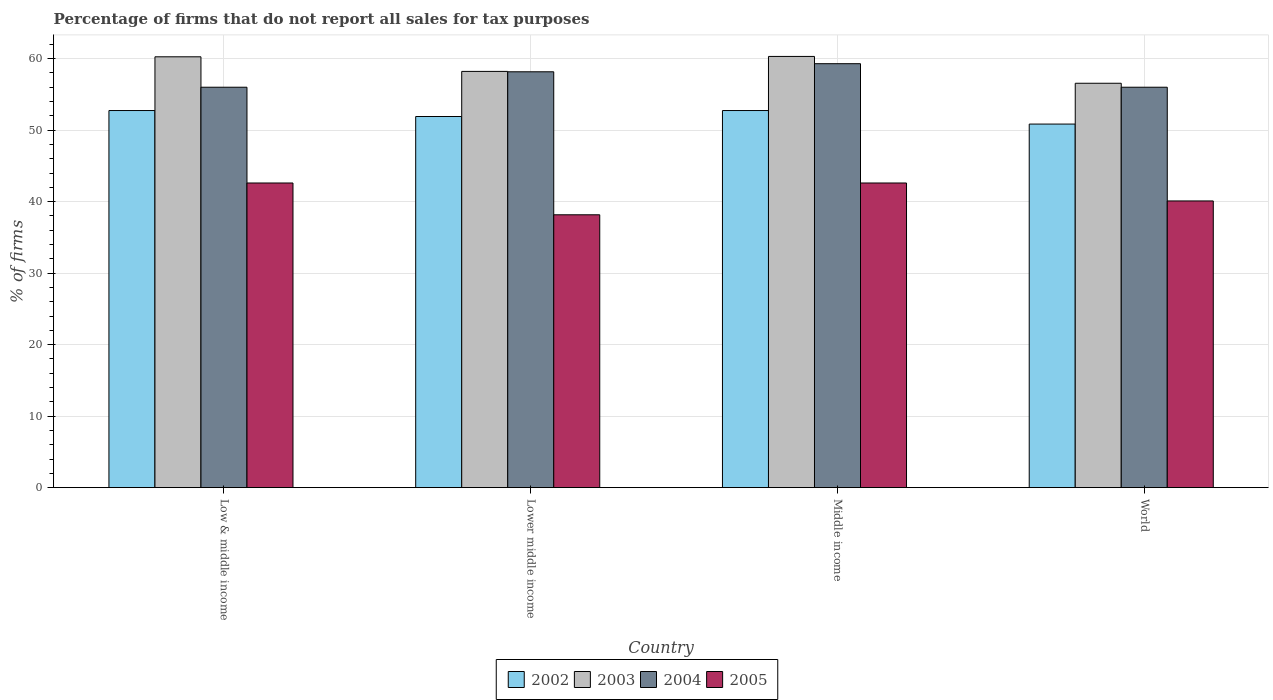How many bars are there on the 3rd tick from the left?
Provide a succinct answer. 4. In how many cases, is the number of bars for a given country not equal to the number of legend labels?
Provide a short and direct response. 0. What is the percentage of firms that do not report all sales for tax purposes in 2002 in Middle income?
Your response must be concise. 52.75. Across all countries, what is the maximum percentage of firms that do not report all sales for tax purposes in 2004?
Ensure brevity in your answer.  59.3. Across all countries, what is the minimum percentage of firms that do not report all sales for tax purposes in 2005?
Give a very brief answer. 38.16. What is the total percentage of firms that do not report all sales for tax purposes in 2005 in the graph?
Your response must be concise. 163.48. What is the difference between the percentage of firms that do not report all sales for tax purposes in 2004 in Lower middle income and that in World?
Offer a terse response. 2.16. What is the difference between the percentage of firms that do not report all sales for tax purposes in 2003 in Low & middle income and the percentage of firms that do not report all sales for tax purposes in 2004 in Middle income?
Keep it short and to the point. 0.96. What is the average percentage of firms that do not report all sales for tax purposes in 2004 per country?
Provide a short and direct response. 57.37. What is the difference between the percentage of firms that do not report all sales for tax purposes of/in 2005 and percentage of firms that do not report all sales for tax purposes of/in 2004 in World?
Make the answer very short. -15.91. What is the ratio of the percentage of firms that do not report all sales for tax purposes in 2004 in Middle income to that in World?
Offer a very short reply. 1.06. Is the percentage of firms that do not report all sales for tax purposes in 2002 in Lower middle income less than that in World?
Your answer should be compact. No. Is the difference between the percentage of firms that do not report all sales for tax purposes in 2005 in Lower middle income and World greater than the difference between the percentage of firms that do not report all sales for tax purposes in 2004 in Lower middle income and World?
Provide a short and direct response. No. What is the difference between the highest and the second highest percentage of firms that do not report all sales for tax purposes in 2005?
Ensure brevity in your answer.  -2.51. What is the difference between the highest and the lowest percentage of firms that do not report all sales for tax purposes in 2004?
Provide a short and direct response. 3.29. In how many countries, is the percentage of firms that do not report all sales for tax purposes in 2004 greater than the average percentage of firms that do not report all sales for tax purposes in 2004 taken over all countries?
Offer a very short reply. 2. Is the sum of the percentage of firms that do not report all sales for tax purposes in 2004 in Low & middle income and Middle income greater than the maximum percentage of firms that do not report all sales for tax purposes in 2002 across all countries?
Keep it short and to the point. Yes. Is it the case that in every country, the sum of the percentage of firms that do not report all sales for tax purposes in 2002 and percentage of firms that do not report all sales for tax purposes in 2004 is greater than the sum of percentage of firms that do not report all sales for tax purposes in 2003 and percentage of firms that do not report all sales for tax purposes in 2005?
Offer a very short reply. No. What does the 4th bar from the left in Middle income represents?
Offer a very short reply. 2005. What does the 4th bar from the right in World represents?
Ensure brevity in your answer.  2002. Is it the case that in every country, the sum of the percentage of firms that do not report all sales for tax purposes in 2002 and percentage of firms that do not report all sales for tax purposes in 2003 is greater than the percentage of firms that do not report all sales for tax purposes in 2004?
Your response must be concise. Yes. How many bars are there?
Offer a terse response. 16. Are all the bars in the graph horizontal?
Your answer should be compact. No. How many countries are there in the graph?
Your answer should be compact. 4. What is the difference between two consecutive major ticks on the Y-axis?
Give a very brief answer. 10. Are the values on the major ticks of Y-axis written in scientific E-notation?
Ensure brevity in your answer.  No. Does the graph contain any zero values?
Offer a very short reply. No. Where does the legend appear in the graph?
Your answer should be compact. Bottom center. How are the legend labels stacked?
Ensure brevity in your answer.  Horizontal. What is the title of the graph?
Offer a terse response. Percentage of firms that do not report all sales for tax purposes. Does "2005" appear as one of the legend labels in the graph?
Give a very brief answer. Yes. What is the label or title of the X-axis?
Ensure brevity in your answer.  Country. What is the label or title of the Y-axis?
Your response must be concise. % of firms. What is the % of firms of 2002 in Low & middle income?
Offer a very short reply. 52.75. What is the % of firms of 2003 in Low & middle income?
Offer a terse response. 60.26. What is the % of firms of 2004 in Low & middle income?
Provide a succinct answer. 56.01. What is the % of firms of 2005 in Low & middle income?
Offer a terse response. 42.61. What is the % of firms of 2002 in Lower middle income?
Make the answer very short. 51.91. What is the % of firms of 2003 in Lower middle income?
Your response must be concise. 58.22. What is the % of firms of 2004 in Lower middle income?
Provide a succinct answer. 58.16. What is the % of firms in 2005 in Lower middle income?
Provide a succinct answer. 38.16. What is the % of firms of 2002 in Middle income?
Provide a short and direct response. 52.75. What is the % of firms in 2003 in Middle income?
Keep it short and to the point. 60.31. What is the % of firms of 2004 in Middle income?
Your response must be concise. 59.3. What is the % of firms in 2005 in Middle income?
Provide a short and direct response. 42.61. What is the % of firms of 2002 in World?
Keep it short and to the point. 50.85. What is the % of firms in 2003 in World?
Provide a short and direct response. 56.56. What is the % of firms in 2004 in World?
Provide a succinct answer. 56.01. What is the % of firms in 2005 in World?
Give a very brief answer. 40.1. Across all countries, what is the maximum % of firms in 2002?
Provide a succinct answer. 52.75. Across all countries, what is the maximum % of firms in 2003?
Offer a very short reply. 60.31. Across all countries, what is the maximum % of firms in 2004?
Ensure brevity in your answer.  59.3. Across all countries, what is the maximum % of firms in 2005?
Offer a very short reply. 42.61. Across all countries, what is the minimum % of firms in 2002?
Your response must be concise. 50.85. Across all countries, what is the minimum % of firms of 2003?
Your response must be concise. 56.56. Across all countries, what is the minimum % of firms of 2004?
Offer a terse response. 56.01. Across all countries, what is the minimum % of firms in 2005?
Ensure brevity in your answer.  38.16. What is the total % of firms in 2002 in the graph?
Your answer should be very brief. 208.25. What is the total % of firms in 2003 in the graph?
Give a very brief answer. 235.35. What is the total % of firms in 2004 in the graph?
Your answer should be compact. 229.47. What is the total % of firms in 2005 in the graph?
Provide a short and direct response. 163.48. What is the difference between the % of firms of 2002 in Low & middle income and that in Lower middle income?
Provide a short and direct response. 0.84. What is the difference between the % of firms of 2003 in Low & middle income and that in Lower middle income?
Offer a terse response. 2.04. What is the difference between the % of firms in 2004 in Low & middle income and that in Lower middle income?
Ensure brevity in your answer.  -2.16. What is the difference between the % of firms of 2005 in Low & middle income and that in Lower middle income?
Ensure brevity in your answer.  4.45. What is the difference between the % of firms of 2002 in Low & middle income and that in Middle income?
Keep it short and to the point. 0. What is the difference between the % of firms in 2003 in Low & middle income and that in Middle income?
Your answer should be compact. -0.05. What is the difference between the % of firms of 2004 in Low & middle income and that in Middle income?
Your answer should be compact. -3.29. What is the difference between the % of firms of 2002 in Low & middle income and that in World?
Your answer should be very brief. 1.89. What is the difference between the % of firms of 2003 in Low & middle income and that in World?
Your answer should be compact. 3.7. What is the difference between the % of firms of 2004 in Low & middle income and that in World?
Your answer should be compact. 0. What is the difference between the % of firms in 2005 in Low & middle income and that in World?
Give a very brief answer. 2.51. What is the difference between the % of firms of 2002 in Lower middle income and that in Middle income?
Make the answer very short. -0.84. What is the difference between the % of firms in 2003 in Lower middle income and that in Middle income?
Ensure brevity in your answer.  -2.09. What is the difference between the % of firms of 2004 in Lower middle income and that in Middle income?
Give a very brief answer. -1.13. What is the difference between the % of firms in 2005 in Lower middle income and that in Middle income?
Offer a very short reply. -4.45. What is the difference between the % of firms in 2002 in Lower middle income and that in World?
Your answer should be very brief. 1.06. What is the difference between the % of firms of 2003 in Lower middle income and that in World?
Your response must be concise. 1.66. What is the difference between the % of firms in 2004 in Lower middle income and that in World?
Provide a short and direct response. 2.16. What is the difference between the % of firms of 2005 in Lower middle income and that in World?
Provide a succinct answer. -1.94. What is the difference between the % of firms in 2002 in Middle income and that in World?
Keep it short and to the point. 1.89. What is the difference between the % of firms of 2003 in Middle income and that in World?
Make the answer very short. 3.75. What is the difference between the % of firms in 2004 in Middle income and that in World?
Provide a short and direct response. 3.29. What is the difference between the % of firms of 2005 in Middle income and that in World?
Ensure brevity in your answer.  2.51. What is the difference between the % of firms of 2002 in Low & middle income and the % of firms of 2003 in Lower middle income?
Give a very brief answer. -5.47. What is the difference between the % of firms of 2002 in Low & middle income and the % of firms of 2004 in Lower middle income?
Make the answer very short. -5.42. What is the difference between the % of firms in 2002 in Low & middle income and the % of firms in 2005 in Lower middle income?
Ensure brevity in your answer.  14.58. What is the difference between the % of firms in 2003 in Low & middle income and the % of firms in 2004 in Lower middle income?
Provide a short and direct response. 2.1. What is the difference between the % of firms of 2003 in Low & middle income and the % of firms of 2005 in Lower middle income?
Provide a short and direct response. 22.1. What is the difference between the % of firms of 2004 in Low & middle income and the % of firms of 2005 in Lower middle income?
Your answer should be very brief. 17.84. What is the difference between the % of firms in 2002 in Low & middle income and the % of firms in 2003 in Middle income?
Offer a very short reply. -7.57. What is the difference between the % of firms of 2002 in Low & middle income and the % of firms of 2004 in Middle income?
Your response must be concise. -6.55. What is the difference between the % of firms in 2002 in Low & middle income and the % of firms in 2005 in Middle income?
Keep it short and to the point. 10.13. What is the difference between the % of firms of 2003 in Low & middle income and the % of firms of 2005 in Middle income?
Make the answer very short. 17.65. What is the difference between the % of firms of 2004 in Low & middle income and the % of firms of 2005 in Middle income?
Your answer should be very brief. 13.39. What is the difference between the % of firms of 2002 in Low & middle income and the % of firms of 2003 in World?
Your response must be concise. -3.81. What is the difference between the % of firms in 2002 in Low & middle income and the % of firms in 2004 in World?
Your answer should be compact. -3.26. What is the difference between the % of firms in 2002 in Low & middle income and the % of firms in 2005 in World?
Your answer should be compact. 12.65. What is the difference between the % of firms of 2003 in Low & middle income and the % of firms of 2004 in World?
Keep it short and to the point. 4.25. What is the difference between the % of firms of 2003 in Low & middle income and the % of firms of 2005 in World?
Offer a very short reply. 20.16. What is the difference between the % of firms in 2004 in Low & middle income and the % of firms in 2005 in World?
Offer a terse response. 15.91. What is the difference between the % of firms of 2002 in Lower middle income and the % of firms of 2003 in Middle income?
Your answer should be compact. -8.4. What is the difference between the % of firms in 2002 in Lower middle income and the % of firms in 2004 in Middle income?
Offer a terse response. -7.39. What is the difference between the % of firms of 2002 in Lower middle income and the % of firms of 2005 in Middle income?
Offer a terse response. 9.3. What is the difference between the % of firms of 2003 in Lower middle income and the % of firms of 2004 in Middle income?
Your response must be concise. -1.08. What is the difference between the % of firms in 2003 in Lower middle income and the % of firms in 2005 in Middle income?
Ensure brevity in your answer.  15.61. What is the difference between the % of firms of 2004 in Lower middle income and the % of firms of 2005 in Middle income?
Ensure brevity in your answer.  15.55. What is the difference between the % of firms in 2002 in Lower middle income and the % of firms in 2003 in World?
Offer a very short reply. -4.65. What is the difference between the % of firms of 2002 in Lower middle income and the % of firms of 2004 in World?
Ensure brevity in your answer.  -4.1. What is the difference between the % of firms of 2002 in Lower middle income and the % of firms of 2005 in World?
Provide a short and direct response. 11.81. What is the difference between the % of firms of 2003 in Lower middle income and the % of firms of 2004 in World?
Ensure brevity in your answer.  2.21. What is the difference between the % of firms in 2003 in Lower middle income and the % of firms in 2005 in World?
Offer a very short reply. 18.12. What is the difference between the % of firms of 2004 in Lower middle income and the % of firms of 2005 in World?
Your answer should be very brief. 18.07. What is the difference between the % of firms in 2002 in Middle income and the % of firms in 2003 in World?
Keep it short and to the point. -3.81. What is the difference between the % of firms of 2002 in Middle income and the % of firms of 2004 in World?
Ensure brevity in your answer.  -3.26. What is the difference between the % of firms in 2002 in Middle income and the % of firms in 2005 in World?
Provide a short and direct response. 12.65. What is the difference between the % of firms of 2003 in Middle income and the % of firms of 2004 in World?
Give a very brief answer. 4.31. What is the difference between the % of firms in 2003 in Middle income and the % of firms in 2005 in World?
Your response must be concise. 20.21. What is the difference between the % of firms of 2004 in Middle income and the % of firms of 2005 in World?
Your answer should be compact. 19.2. What is the average % of firms in 2002 per country?
Keep it short and to the point. 52.06. What is the average % of firms in 2003 per country?
Make the answer very short. 58.84. What is the average % of firms in 2004 per country?
Offer a terse response. 57.37. What is the average % of firms of 2005 per country?
Ensure brevity in your answer.  40.87. What is the difference between the % of firms of 2002 and % of firms of 2003 in Low & middle income?
Make the answer very short. -7.51. What is the difference between the % of firms of 2002 and % of firms of 2004 in Low & middle income?
Provide a short and direct response. -3.26. What is the difference between the % of firms in 2002 and % of firms in 2005 in Low & middle income?
Your response must be concise. 10.13. What is the difference between the % of firms in 2003 and % of firms in 2004 in Low & middle income?
Provide a succinct answer. 4.25. What is the difference between the % of firms in 2003 and % of firms in 2005 in Low & middle income?
Offer a very short reply. 17.65. What is the difference between the % of firms of 2004 and % of firms of 2005 in Low & middle income?
Provide a succinct answer. 13.39. What is the difference between the % of firms in 2002 and % of firms in 2003 in Lower middle income?
Provide a short and direct response. -6.31. What is the difference between the % of firms in 2002 and % of firms in 2004 in Lower middle income?
Provide a succinct answer. -6.26. What is the difference between the % of firms in 2002 and % of firms in 2005 in Lower middle income?
Give a very brief answer. 13.75. What is the difference between the % of firms of 2003 and % of firms of 2004 in Lower middle income?
Make the answer very short. 0.05. What is the difference between the % of firms in 2003 and % of firms in 2005 in Lower middle income?
Make the answer very short. 20.06. What is the difference between the % of firms in 2004 and % of firms in 2005 in Lower middle income?
Provide a succinct answer. 20. What is the difference between the % of firms in 2002 and % of firms in 2003 in Middle income?
Ensure brevity in your answer.  -7.57. What is the difference between the % of firms in 2002 and % of firms in 2004 in Middle income?
Your response must be concise. -6.55. What is the difference between the % of firms in 2002 and % of firms in 2005 in Middle income?
Offer a very short reply. 10.13. What is the difference between the % of firms of 2003 and % of firms of 2004 in Middle income?
Provide a short and direct response. 1.02. What is the difference between the % of firms of 2003 and % of firms of 2005 in Middle income?
Offer a terse response. 17.7. What is the difference between the % of firms of 2004 and % of firms of 2005 in Middle income?
Give a very brief answer. 16.69. What is the difference between the % of firms of 2002 and % of firms of 2003 in World?
Give a very brief answer. -5.71. What is the difference between the % of firms of 2002 and % of firms of 2004 in World?
Give a very brief answer. -5.15. What is the difference between the % of firms of 2002 and % of firms of 2005 in World?
Provide a short and direct response. 10.75. What is the difference between the % of firms of 2003 and % of firms of 2004 in World?
Keep it short and to the point. 0.56. What is the difference between the % of firms of 2003 and % of firms of 2005 in World?
Your answer should be very brief. 16.46. What is the difference between the % of firms of 2004 and % of firms of 2005 in World?
Your answer should be very brief. 15.91. What is the ratio of the % of firms in 2002 in Low & middle income to that in Lower middle income?
Ensure brevity in your answer.  1.02. What is the ratio of the % of firms of 2003 in Low & middle income to that in Lower middle income?
Your response must be concise. 1.04. What is the ratio of the % of firms in 2004 in Low & middle income to that in Lower middle income?
Your answer should be very brief. 0.96. What is the ratio of the % of firms of 2005 in Low & middle income to that in Lower middle income?
Ensure brevity in your answer.  1.12. What is the ratio of the % of firms of 2002 in Low & middle income to that in Middle income?
Your answer should be compact. 1. What is the ratio of the % of firms of 2003 in Low & middle income to that in Middle income?
Your response must be concise. 1. What is the ratio of the % of firms in 2004 in Low & middle income to that in Middle income?
Provide a short and direct response. 0.94. What is the ratio of the % of firms of 2005 in Low & middle income to that in Middle income?
Your answer should be very brief. 1. What is the ratio of the % of firms in 2002 in Low & middle income to that in World?
Your answer should be very brief. 1.04. What is the ratio of the % of firms of 2003 in Low & middle income to that in World?
Give a very brief answer. 1.07. What is the ratio of the % of firms in 2005 in Low & middle income to that in World?
Your response must be concise. 1.06. What is the ratio of the % of firms in 2002 in Lower middle income to that in Middle income?
Offer a very short reply. 0.98. What is the ratio of the % of firms of 2003 in Lower middle income to that in Middle income?
Offer a terse response. 0.97. What is the ratio of the % of firms of 2004 in Lower middle income to that in Middle income?
Your answer should be very brief. 0.98. What is the ratio of the % of firms in 2005 in Lower middle income to that in Middle income?
Your response must be concise. 0.9. What is the ratio of the % of firms of 2002 in Lower middle income to that in World?
Provide a succinct answer. 1.02. What is the ratio of the % of firms in 2003 in Lower middle income to that in World?
Ensure brevity in your answer.  1.03. What is the ratio of the % of firms of 2004 in Lower middle income to that in World?
Offer a terse response. 1.04. What is the ratio of the % of firms of 2005 in Lower middle income to that in World?
Give a very brief answer. 0.95. What is the ratio of the % of firms in 2002 in Middle income to that in World?
Ensure brevity in your answer.  1.04. What is the ratio of the % of firms of 2003 in Middle income to that in World?
Make the answer very short. 1.07. What is the ratio of the % of firms of 2004 in Middle income to that in World?
Your response must be concise. 1.06. What is the ratio of the % of firms in 2005 in Middle income to that in World?
Ensure brevity in your answer.  1.06. What is the difference between the highest and the second highest % of firms in 2002?
Keep it short and to the point. 0. What is the difference between the highest and the second highest % of firms of 2003?
Your response must be concise. 0.05. What is the difference between the highest and the second highest % of firms of 2004?
Offer a terse response. 1.13. What is the difference between the highest and the second highest % of firms of 2005?
Your answer should be compact. 0. What is the difference between the highest and the lowest % of firms in 2002?
Provide a succinct answer. 1.89. What is the difference between the highest and the lowest % of firms of 2003?
Give a very brief answer. 3.75. What is the difference between the highest and the lowest % of firms in 2004?
Give a very brief answer. 3.29. What is the difference between the highest and the lowest % of firms in 2005?
Your response must be concise. 4.45. 